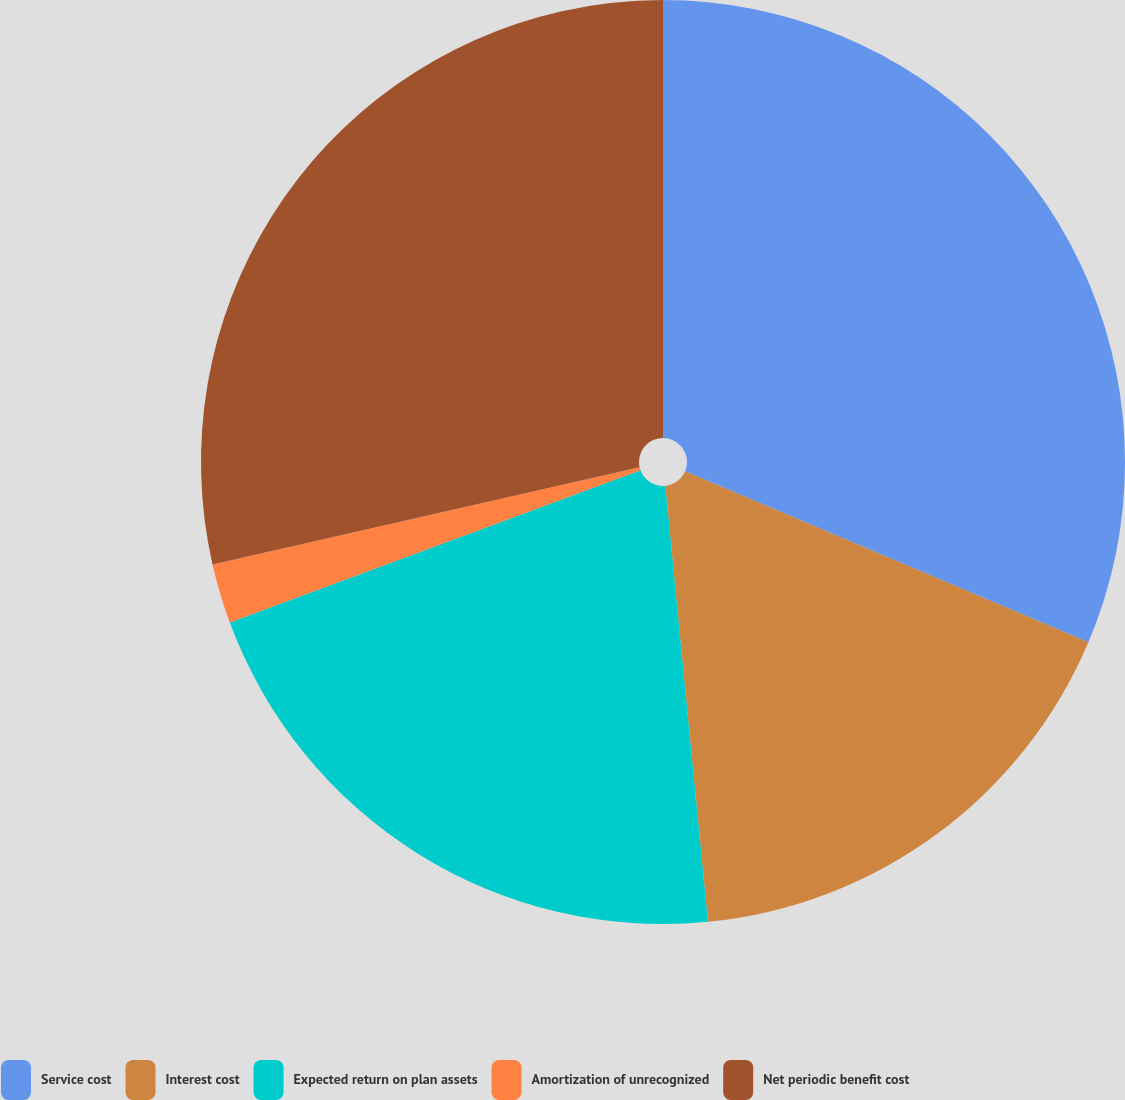<chart> <loc_0><loc_0><loc_500><loc_500><pie_chart><fcel>Service cost<fcel>Interest cost<fcel>Expected return on plan assets<fcel>Amortization of unrecognized<fcel>Net periodic benefit cost<nl><fcel>31.38%<fcel>17.07%<fcel>20.9%<fcel>2.09%<fcel>28.56%<nl></chart> 